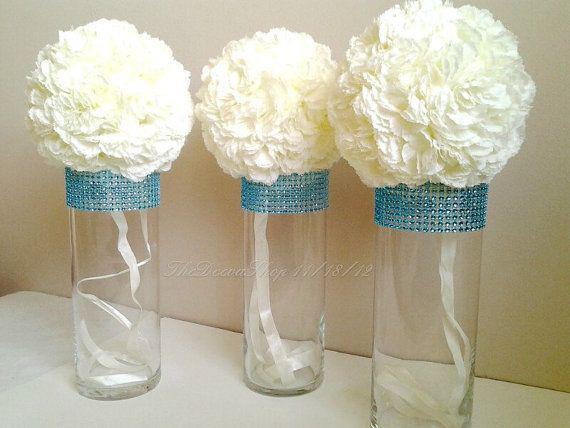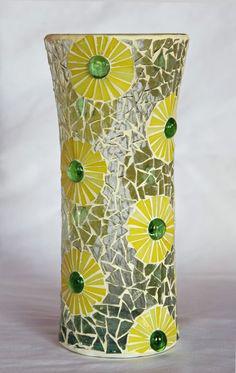The first image is the image on the left, the second image is the image on the right. Assess this claim about the two images: "At least one photo features cactus-shaped vases.". Correct or not? Answer yes or no. No. The first image is the image on the left, the second image is the image on the right. Examine the images to the left and right. Is the description "At least one image features vases that look like cacti." accurate? Answer yes or no. No. 